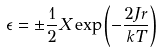Convert formula to latex. <formula><loc_0><loc_0><loc_500><loc_500>\epsilon = \pm \frac { 1 } { 2 } X \exp \left ( - \frac { 2 J r } { k T } \right )</formula> 